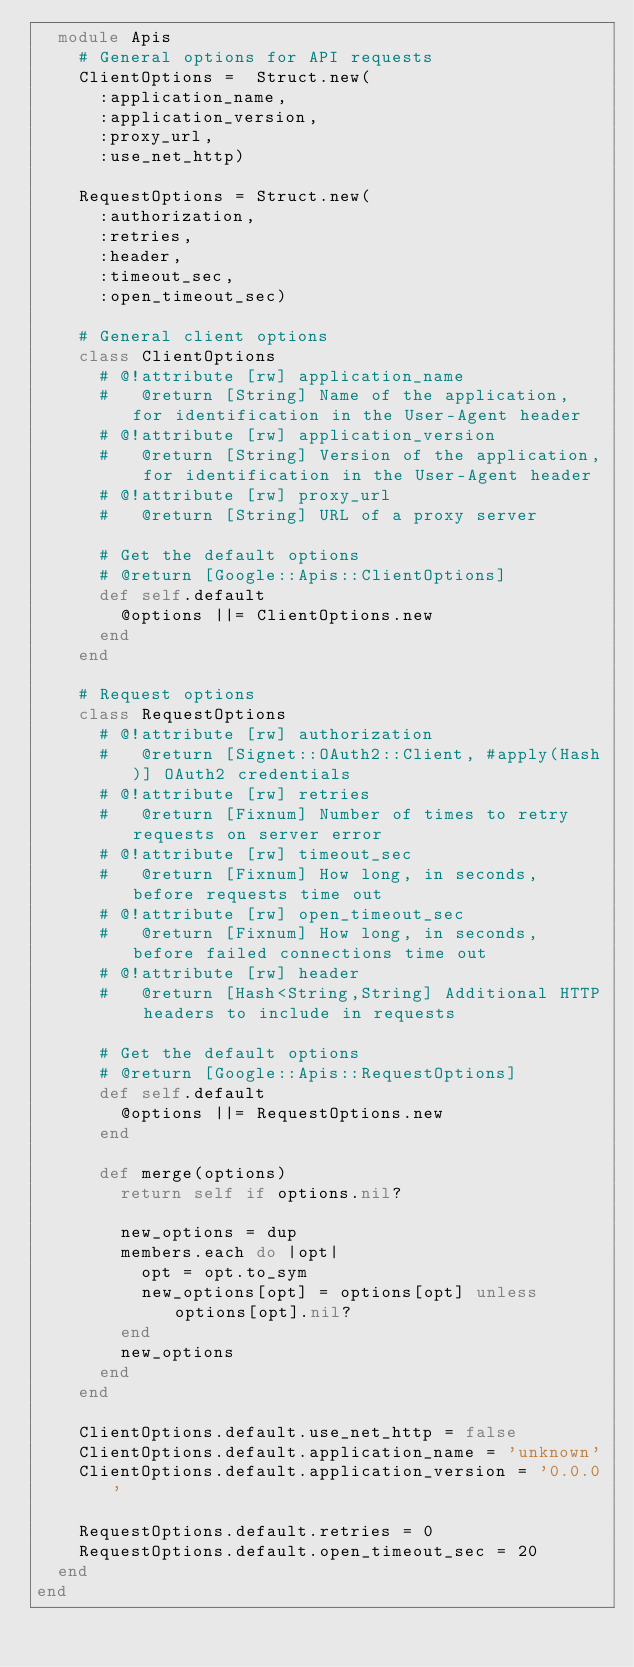Convert code to text. <code><loc_0><loc_0><loc_500><loc_500><_Ruby_>  module Apis
    # General options for API requests
    ClientOptions =  Struct.new(
      :application_name,
      :application_version,
      :proxy_url,
      :use_net_http)

    RequestOptions = Struct.new(
      :authorization,
      :retries,
      :header,
      :timeout_sec,
      :open_timeout_sec)

    # General client options
    class ClientOptions
      # @!attribute [rw] application_name
      #   @return [String] Name of the application, for identification in the User-Agent header
      # @!attribute [rw] application_version
      #   @return [String] Version of the application, for identification in the User-Agent header
      # @!attribute [rw] proxy_url
      #   @return [String] URL of a proxy server

      # Get the default options
      # @return [Google::Apis::ClientOptions]
      def self.default
        @options ||= ClientOptions.new
      end
    end

    # Request options
    class RequestOptions
      # @!attribute [rw] authorization
      #   @return [Signet::OAuth2::Client, #apply(Hash)] OAuth2 credentials
      # @!attribute [rw] retries
      #   @return [Fixnum] Number of times to retry requests on server error
      # @!attribute [rw] timeout_sec
      #   @return [Fixnum] How long, in seconds, before requests time out
      # @!attribute [rw] open_timeout_sec
      #   @return [Fixnum] How long, in seconds, before failed connections time out
      # @!attribute [rw] header
      #   @return [Hash<String,String] Additional HTTP headers to include in requests

      # Get the default options
      # @return [Google::Apis::RequestOptions]
      def self.default
        @options ||= RequestOptions.new
      end

      def merge(options)
        return self if options.nil?

        new_options = dup
        members.each do |opt|
          opt = opt.to_sym
          new_options[opt] = options[opt] unless options[opt].nil?
        end
        new_options
      end
    end
    
    ClientOptions.default.use_net_http = false
    ClientOptions.default.application_name = 'unknown'
    ClientOptions.default.application_version = '0.0.0'

    RequestOptions.default.retries = 0
    RequestOptions.default.open_timeout_sec = 20
  end
end
</code> 